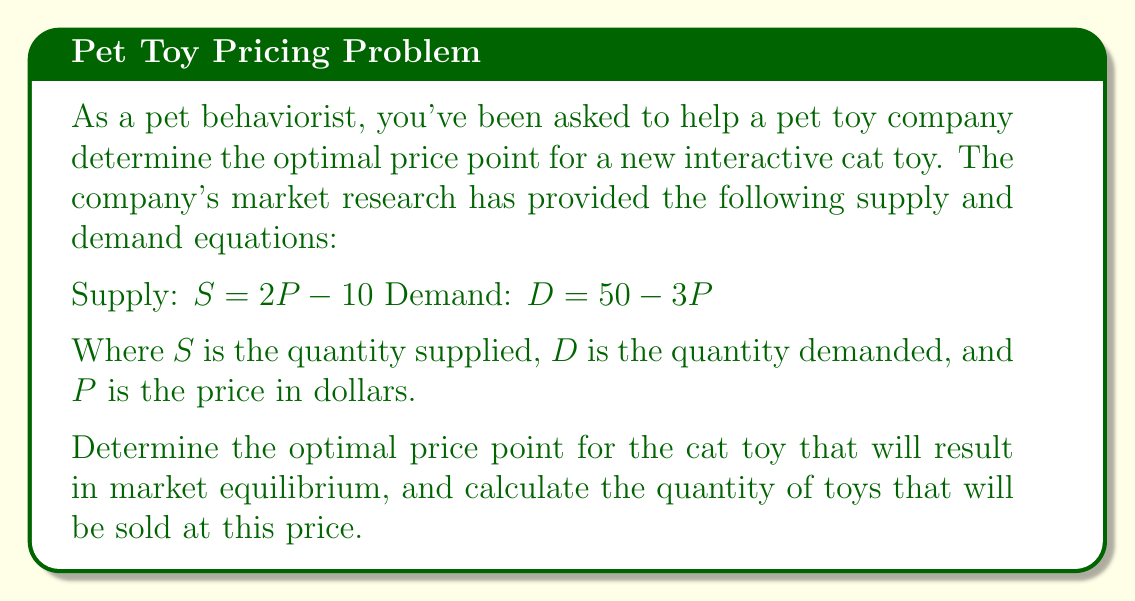Give your solution to this math problem. To solve this problem, we need to follow these steps:

1. Understand that market equilibrium occurs when supply equals demand:
   $S = D$

2. Substitute the given equations:
   $2P - 10 = 50 - 3P$

3. Solve for $P$:
   $2P - 10 = 50 - 3P$
   $2P + 3P = 50 + 10$
   $5P = 60$
   $P = 12$

4. Now that we know the equilibrium price, we can calculate the quantity by substituting $P = 12$ into either the supply or demand equation. Let's use the supply equation:

   $S = 2P - 10$
   $S = 2(12) - 10$
   $S = 24 - 10$
   $S = 14$

5. We can verify this using the demand equation:
   $D = 50 - 3P$
   $D = 50 - 3(12)$
   $D = 50 - 36$
   $D = 14$

Both equations yield the same quantity, confirming our solution.
Answer: The optimal price point for the new interactive cat toy is $12. At this price, 14 units of the toy will be sold, achieving market equilibrium. 